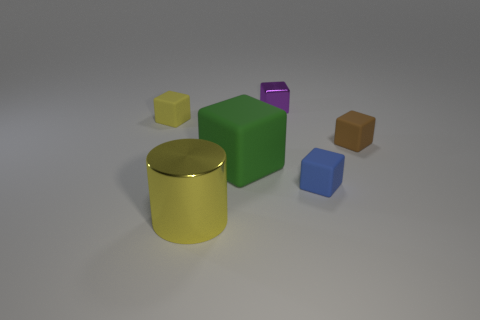Subtract all brown rubber cubes. How many cubes are left? 4 Subtract all blue cubes. How many cubes are left? 4 Subtract 2 blocks. How many blocks are left? 3 Add 3 small rubber things. How many objects exist? 9 Subtract all gray cubes. Subtract all gray cylinders. How many cubes are left? 5 Add 5 cylinders. How many cylinders exist? 6 Subtract 0 green cylinders. How many objects are left? 6 Subtract all blocks. How many objects are left? 1 Subtract all small rubber blocks. Subtract all green things. How many objects are left? 2 Add 2 small metallic objects. How many small metallic objects are left? 3 